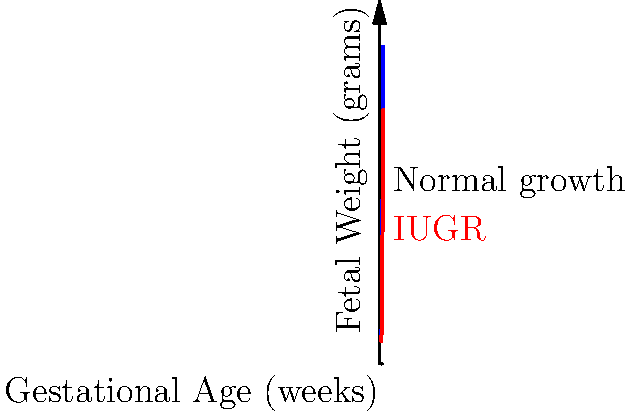As a midwife, you're monitoring the growth of a fetus. At 32 weeks gestation, the estimated fetal weight is 1400 grams. Based on the fetal growth curves shown in the coordinate system, what conclusion can you draw about this fetus's growth, and what action should you consider? To answer this question, let's analyze the growth curve step-by-step:

1. Locate the point on the graph:
   - X-axis: 32 weeks gestation
   - Y-axis: 1400 grams

2. Compare with the curves:
   - The blue curve represents normal fetal growth
   - The red curve represents Intrauterine Growth Restriction (IUGR)

3. Observe that the point (32 weeks, 1400 grams) falls on the red IUGR curve:
   - At 32 weeks, normal weight is approximately 1800 grams
   - The fetus in question weighs 1400 grams, which is below normal

4. Conclusion:
   - The fetus shows signs of Intrauterine Growth Restriction (IUGR)

5. Action to consider:
   - As a midwife, you should refer the patient to an obstetrician for further evaluation and management
   - Additional monitoring and possibly interventions may be necessary to ensure the best outcome for the fetus
Answer: IUGR suspected; refer to obstetrician 